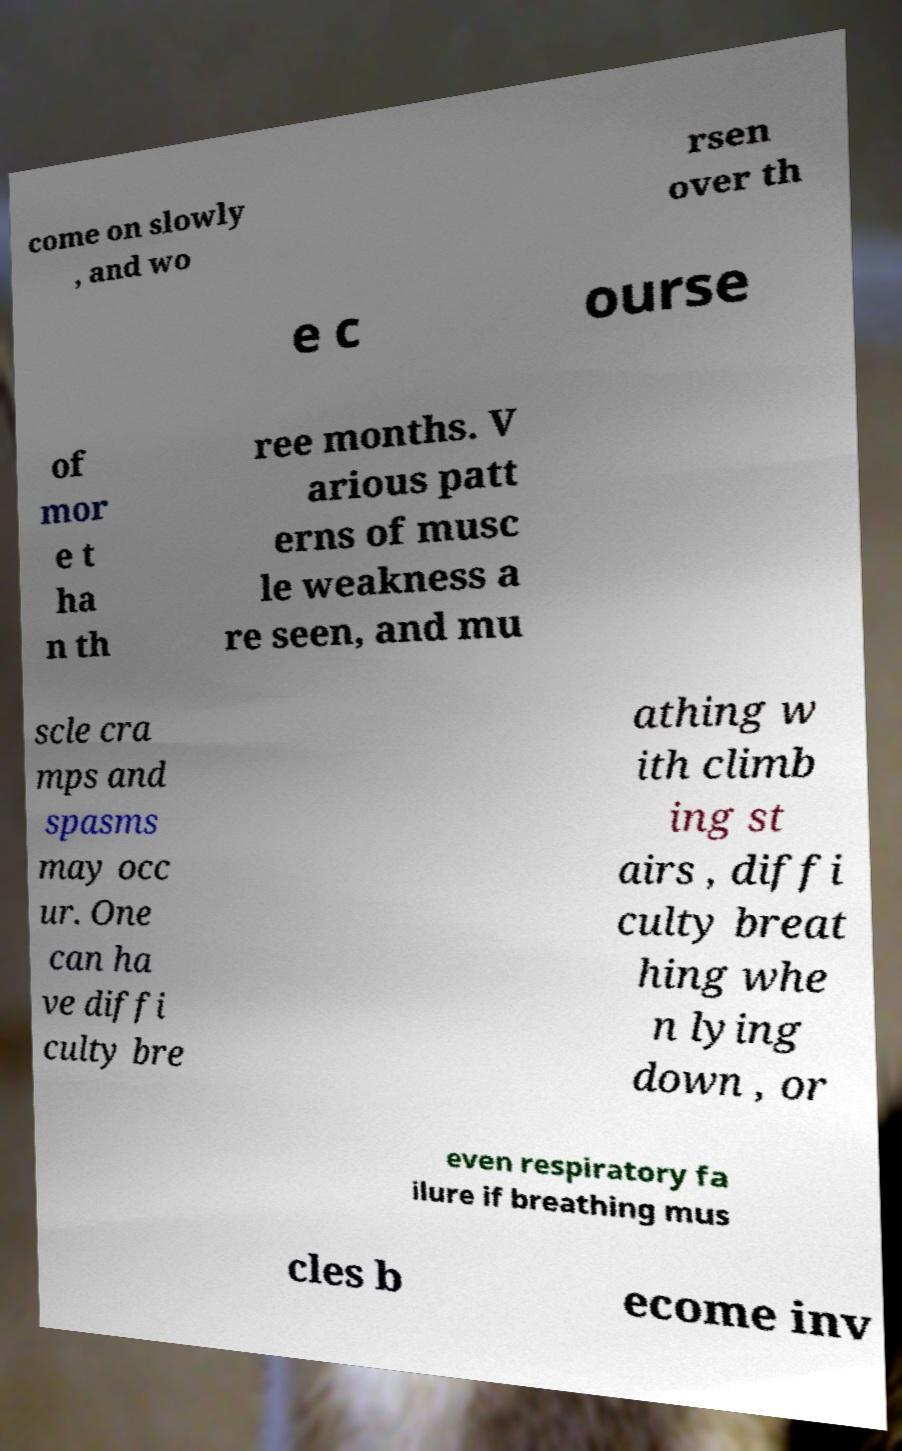Could you assist in decoding the text presented in this image and type it out clearly? come on slowly , and wo rsen over th e c ourse of mor e t ha n th ree months. V arious patt erns of musc le weakness a re seen, and mu scle cra mps and spasms may occ ur. One can ha ve diffi culty bre athing w ith climb ing st airs , diffi culty breat hing whe n lying down , or even respiratory fa ilure if breathing mus cles b ecome inv 